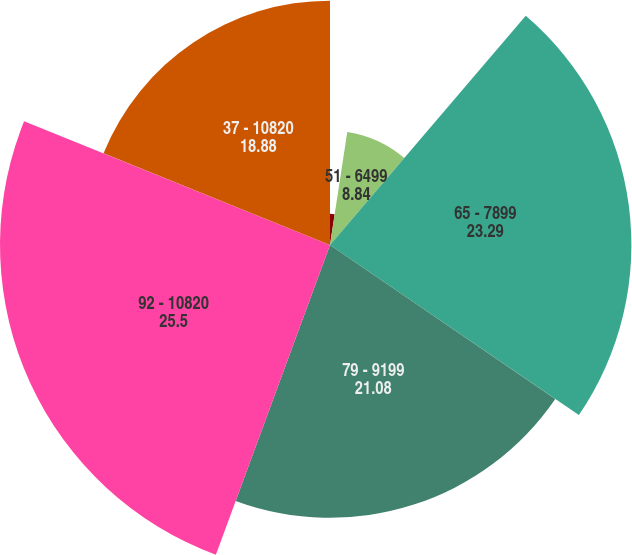Convert chart to OTSL. <chart><loc_0><loc_0><loc_500><loc_500><pie_chart><fcel>37 - 5099<fcel>51 - 6499<fcel>65 - 7899<fcel>79 - 9199<fcel>92 - 10820<fcel>37 - 10820<nl><fcel>2.41%<fcel>8.84%<fcel>23.29%<fcel>21.08%<fcel>25.5%<fcel>18.88%<nl></chart> 